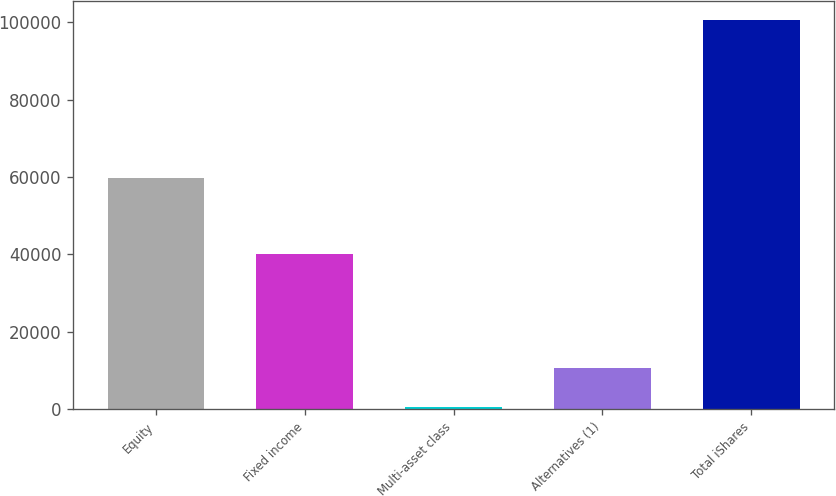Convert chart to OTSL. <chart><loc_0><loc_0><loc_500><loc_500><bar_chart><fcel>Equity<fcel>Fixed income<fcel>Multi-asset class<fcel>Alternatives (1)<fcel>Total iShares<nl><fcel>59626<fcel>40007<fcel>439<fcel>10455.2<fcel>100601<nl></chart> 